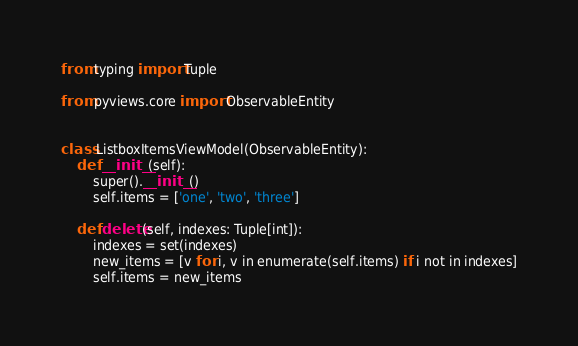<code> <loc_0><loc_0><loc_500><loc_500><_Python_>from typing import Tuple

from pyviews.core import ObservableEntity


class ListboxItemsViewModel(ObservableEntity):
    def __init__(self):
        super().__init__()
        self.items = ['one', 'two', 'three']

    def delete(self, indexes: Tuple[int]):
        indexes = set(indexes)
        new_items = [v for i, v in enumerate(self.items) if i not in indexes]
        self.items = new_items
</code> 